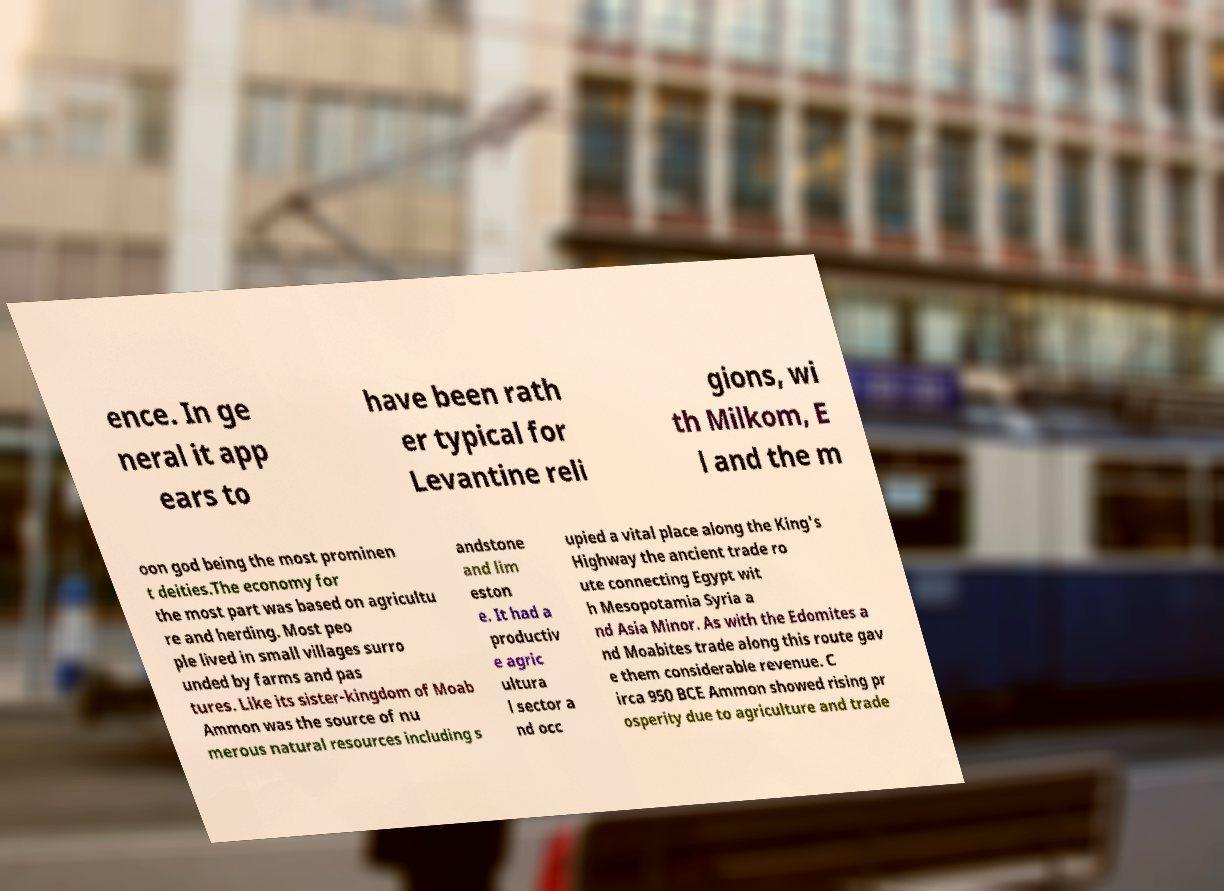Could you assist in decoding the text presented in this image and type it out clearly? ence. In ge neral it app ears to have been rath er typical for Levantine reli gions, wi th Milkom, E l and the m oon god being the most prominen t deities.The economy for the most part was based on agricultu re and herding. Most peo ple lived in small villages surro unded by farms and pas tures. Like its sister-kingdom of Moab Ammon was the source of nu merous natural resources including s andstone and lim eston e. It had a productiv e agric ultura l sector a nd occ upied a vital place along the King's Highway the ancient trade ro ute connecting Egypt wit h Mesopotamia Syria a nd Asia Minor. As with the Edomites a nd Moabites trade along this route gav e them considerable revenue. C irca 950 BCE Ammon showed rising pr osperity due to agriculture and trade 